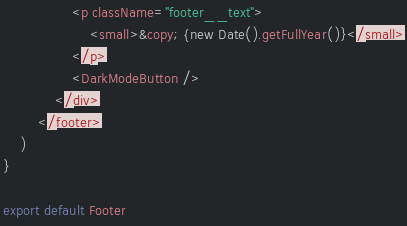Convert code to text. <code><loc_0><loc_0><loc_500><loc_500><_JavaScript_>                <p className="footer__text">
                    <small>&copy; {new Date().getFullYear()}</small>
                </p>
                <DarkModeButton />
            </div>
        </footer>
    )
}

export default Footer
</code> 